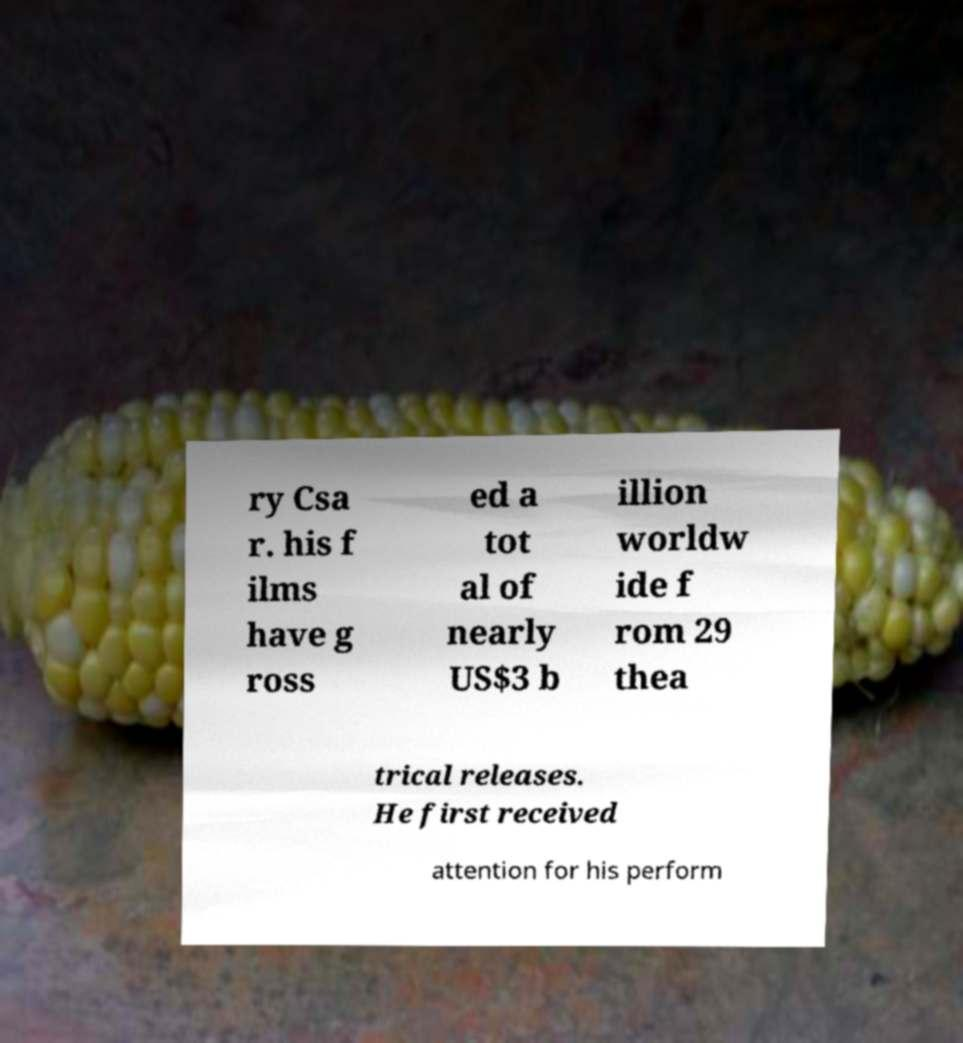There's text embedded in this image that I need extracted. Can you transcribe it verbatim? ry Csa r. his f ilms have g ross ed a tot al of nearly US$3 b illion worldw ide f rom 29 thea trical releases. He first received attention for his perform 